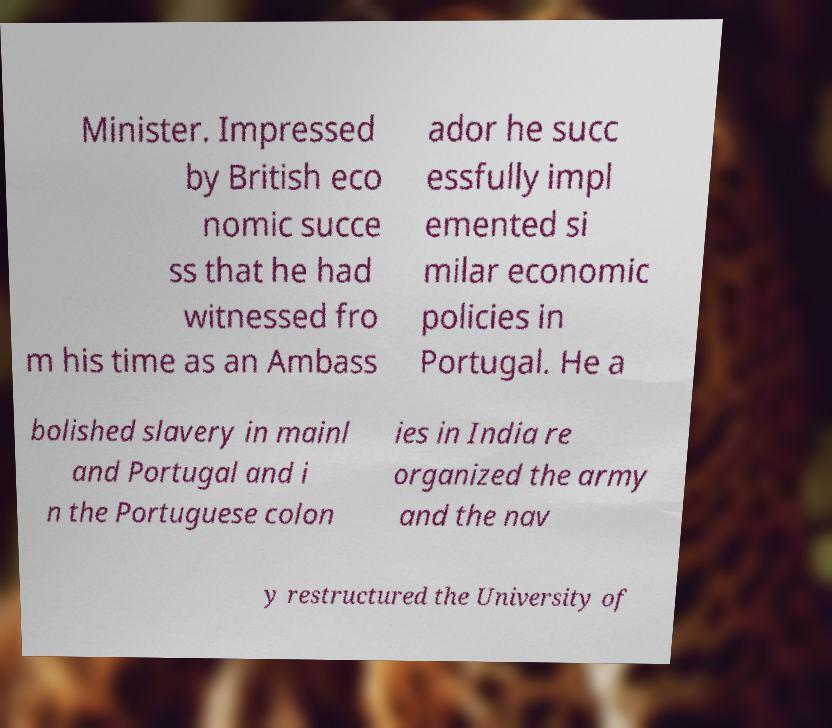There's text embedded in this image that I need extracted. Can you transcribe it verbatim? Minister. Impressed by British eco nomic succe ss that he had witnessed fro m his time as an Ambass ador he succ essfully impl emented si milar economic policies in Portugal. He a bolished slavery in mainl and Portugal and i n the Portuguese colon ies in India re organized the army and the nav y restructured the University of 